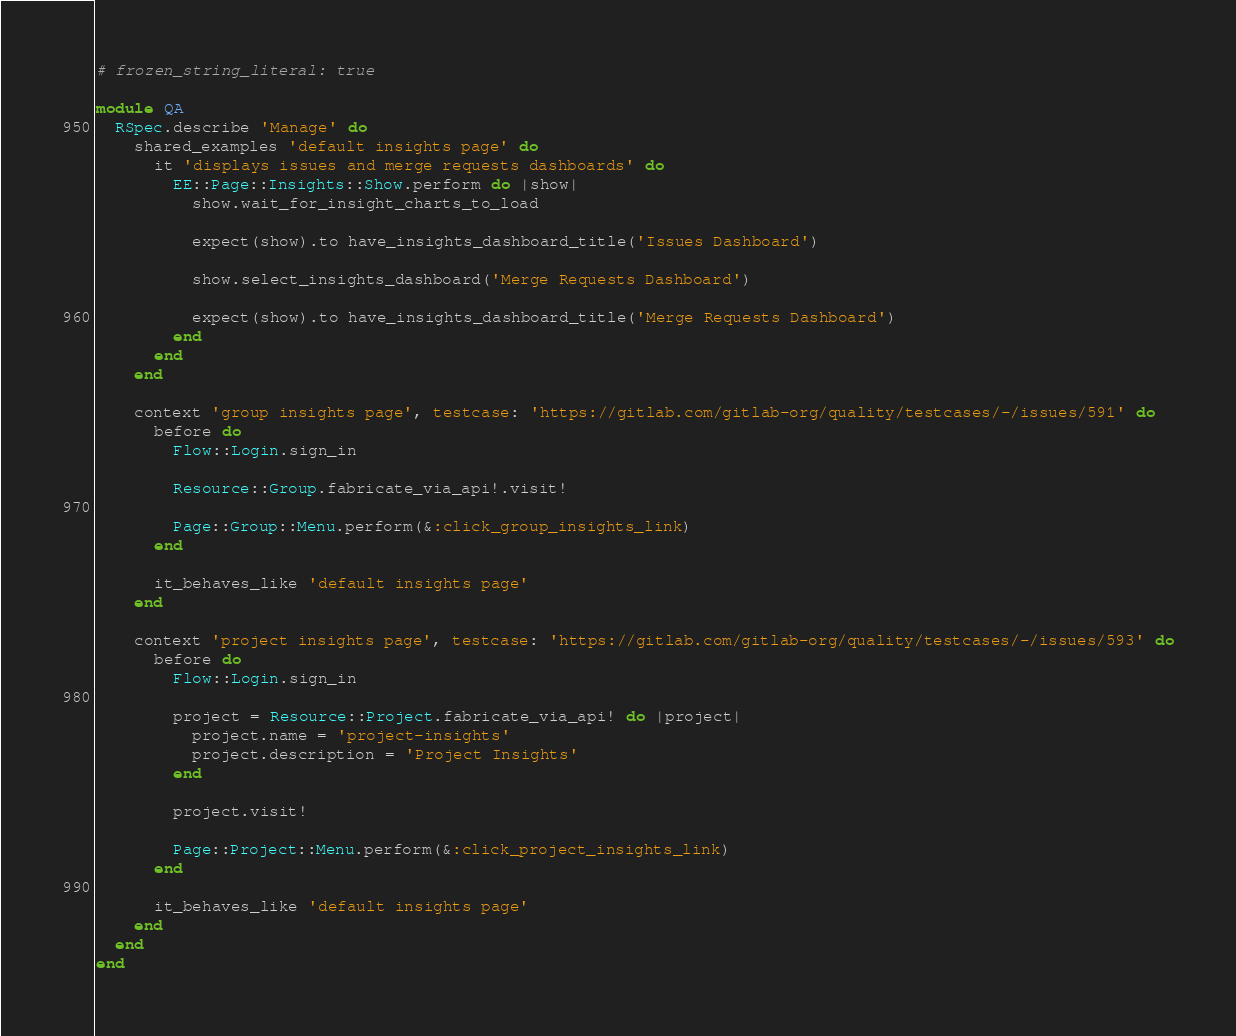Convert code to text. <code><loc_0><loc_0><loc_500><loc_500><_Ruby_># frozen_string_literal: true

module QA
  RSpec.describe 'Manage' do
    shared_examples 'default insights page' do
      it 'displays issues and merge requests dashboards' do
        EE::Page::Insights::Show.perform do |show|
          show.wait_for_insight_charts_to_load

          expect(show).to have_insights_dashboard_title('Issues Dashboard')

          show.select_insights_dashboard('Merge Requests Dashboard')

          expect(show).to have_insights_dashboard_title('Merge Requests Dashboard')
        end
      end
    end

    context 'group insights page', testcase: 'https://gitlab.com/gitlab-org/quality/testcases/-/issues/591' do
      before do
        Flow::Login.sign_in

        Resource::Group.fabricate_via_api!.visit!

        Page::Group::Menu.perform(&:click_group_insights_link)
      end

      it_behaves_like 'default insights page'
    end

    context 'project insights page', testcase: 'https://gitlab.com/gitlab-org/quality/testcases/-/issues/593' do
      before do
        Flow::Login.sign_in

        project = Resource::Project.fabricate_via_api! do |project|
          project.name = 'project-insights'
          project.description = 'Project Insights'
        end

        project.visit!

        Page::Project::Menu.perform(&:click_project_insights_link)
      end

      it_behaves_like 'default insights page'
    end
  end
end
</code> 